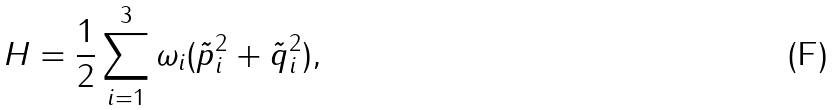<formula> <loc_0><loc_0><loc_500><loc_500>H = \frac { 1 } { 2 } \sum _ { i = 1 } ^ { 3 } \omega _ { i } ( \tilde { p } _ { i } ^ { 2 } + \tilde { q } _ { i } ^ { 2 } ) ,</formula> 